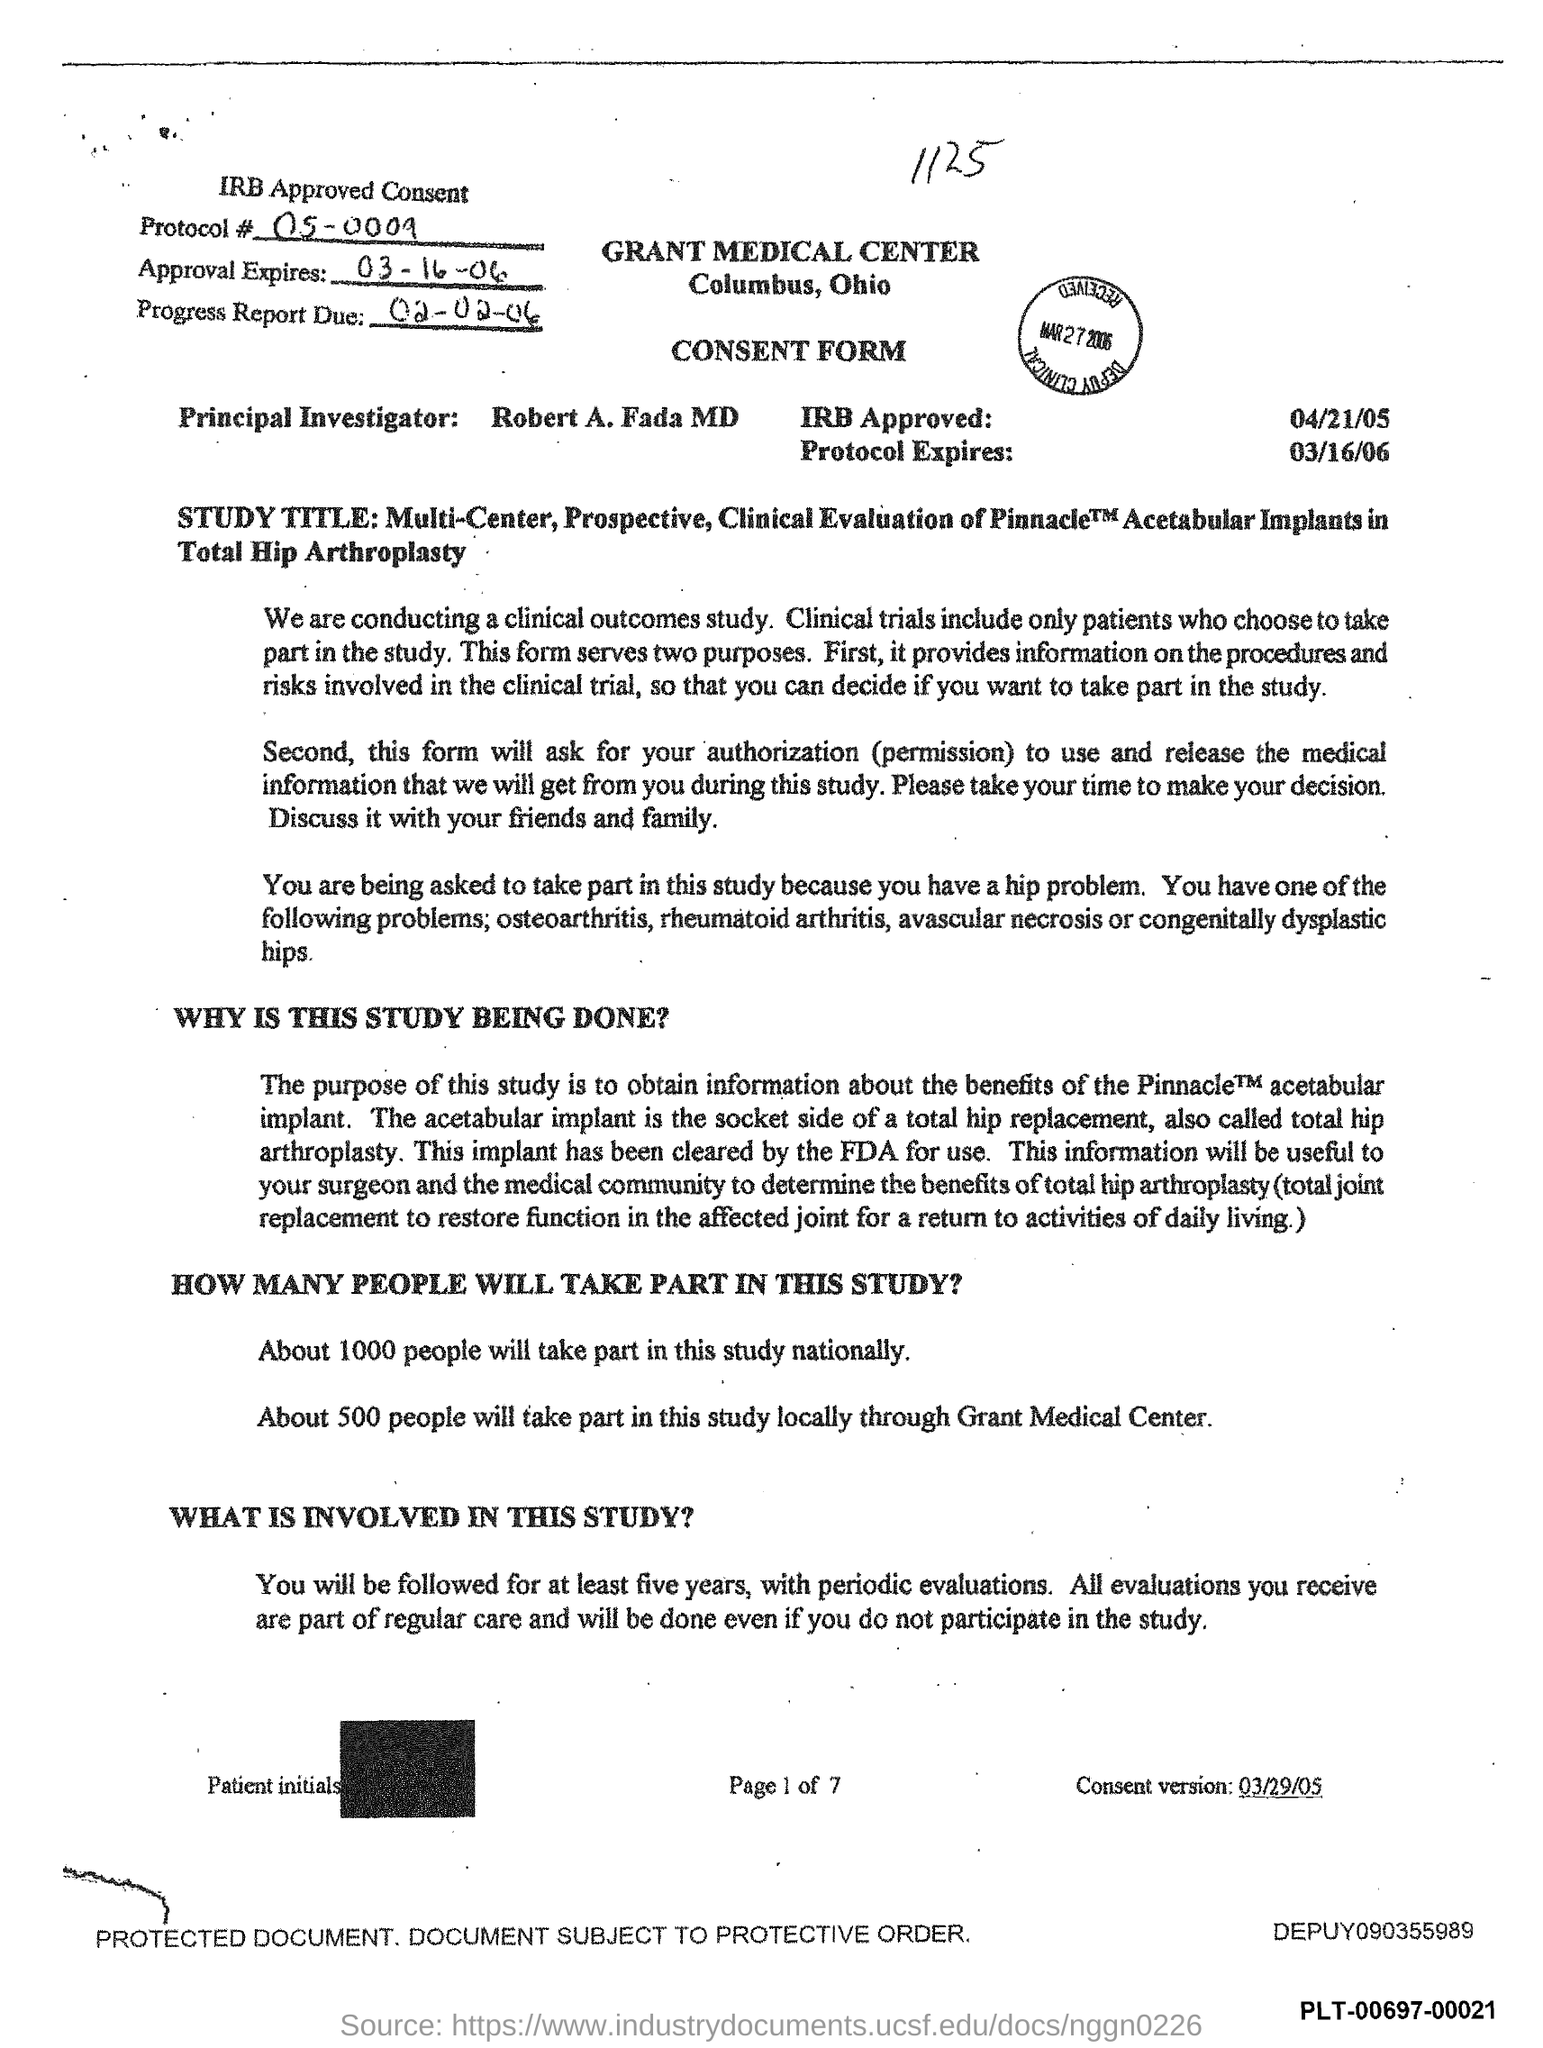Give some essential details in this illustration. On what date does the approval expire? It is March 16, 2006. On what date does the protocol expire? It is March 16, 2006. The IRB approved the date of April 21, 2005. The protocol number is 05-0009. 